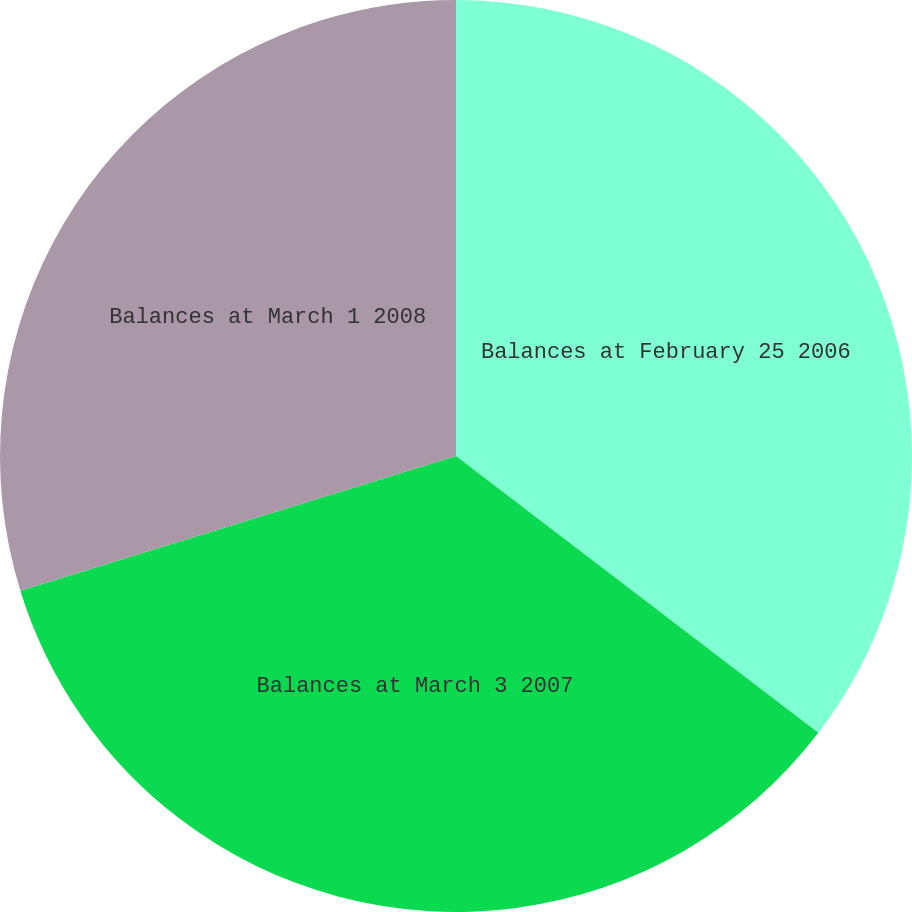Convert chart to OTSL. <chart><loc_0><loc_0><loc_500><loc_500><pie_chart><fcel>Balances at February 25 2006<fcel>Balances at March 3 2007<fcel>Balances at March 1 2008<nl><fcel>35.38%<fcel>34.84%<fcel>29.77%<nl></chart> 